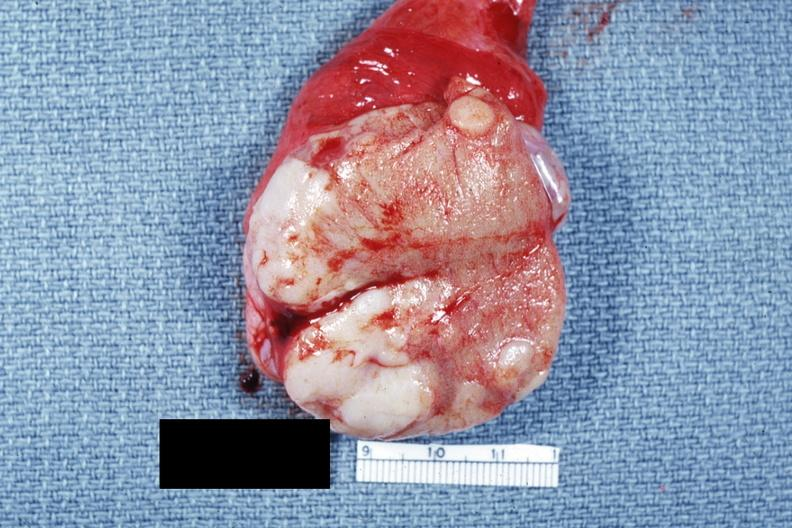does this image show close-up tumor well shown primary not stated said to be adenocarcinoma?
Answer the question using a single word or phrase. Yes 